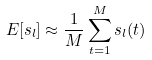<formula> <loc_0><loc_0><loc_500><loc_500>E [ { s _ { l } } ] \approx \frac { 1 } { M } \sum _ { t = 1 } ^ { M } s _ { l } ( t )</formula> 